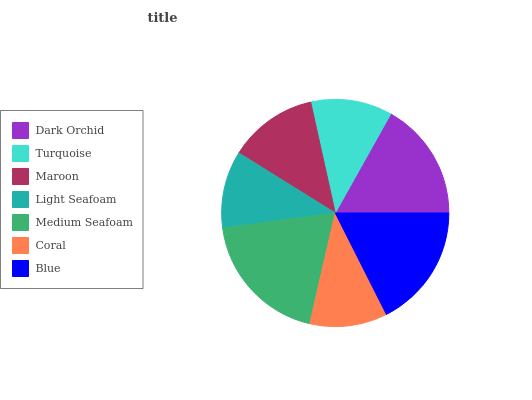Is Light Seafoam the minimum?
Answer yes or no. Yes. Is Medium Seafoam the maximum?
Answer yes or no. Yes. Is Turquoise the minimum?
Answer yes or no. No. Is Turquoise the maximum?
Answer yes or no. No. Is Dark Orchid greater than Turquoise?
Answer yes or no. Yes. Is Turquoise less than Dark Orchid?
Answer yes or no. Yes. Is Turquoise greater than Dark Orchid?
Answer yes or no. No. Is Dark Orchid less than Turquoise?
Answer yes or no. No. Is Maroon the high median?
Answer yes or no. Yes. Is Maroon the low median?
Answer yes or no. Yes. Is Blue the high median?
Answer yes or no. No. Is Medium Seafoam the low median?
Answer yes or no. No. 